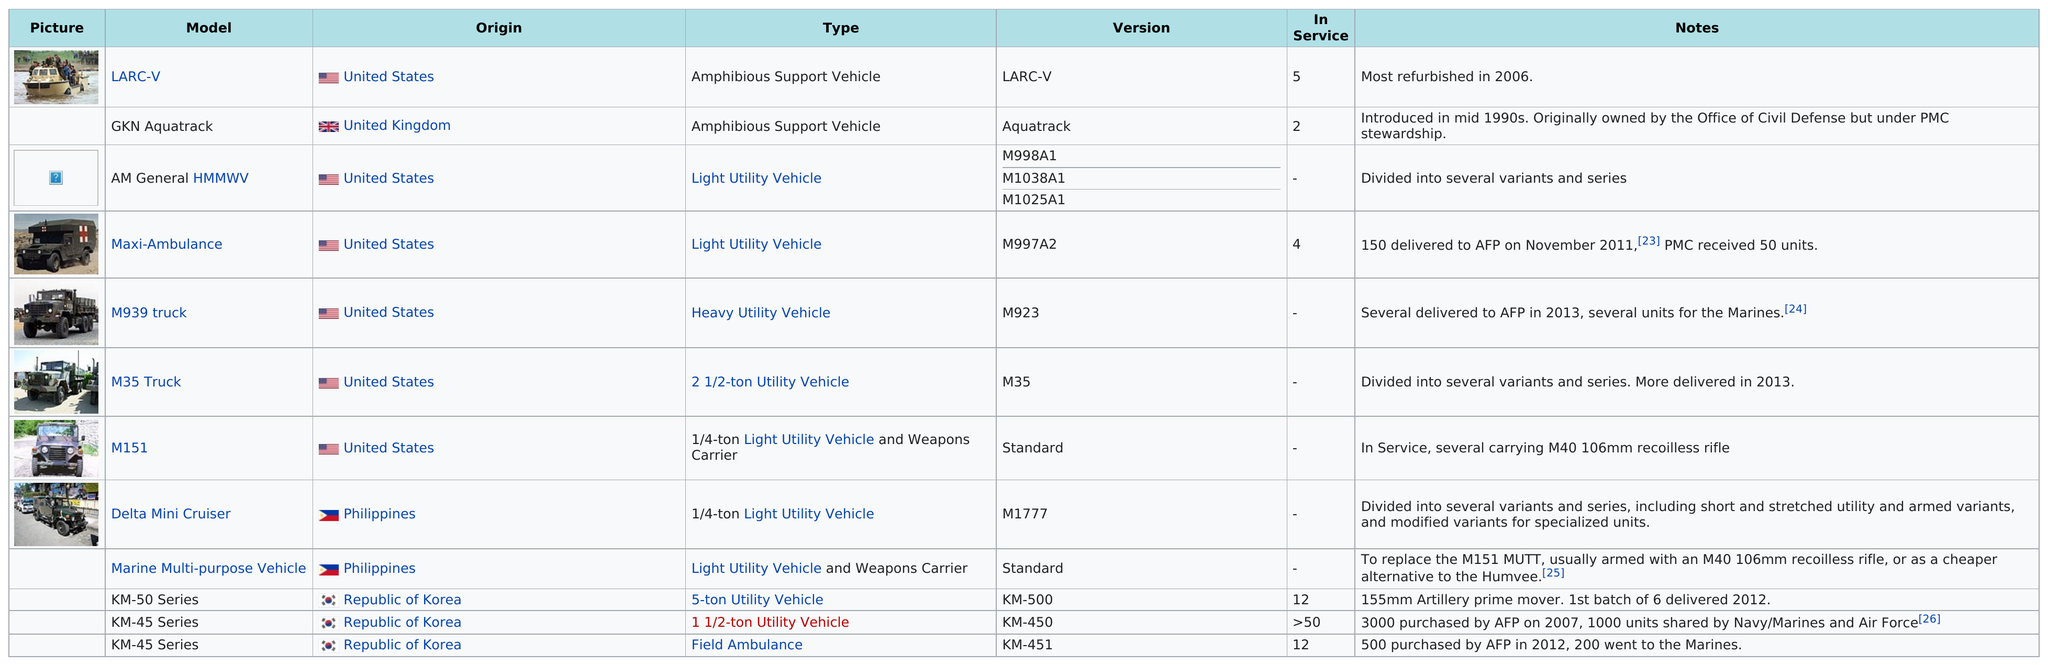Highlight a few significant elements in this photo. Yes, in the chart, the AM General HMMWV is listed before the Maxi-Ambulance. The total number of vehicles originating from the United Kingdom is 1.. The total number of models listed is 12. According to classification, there are 5 light utility vehicle models. It is estimated that there are approximately 5 utility vehicle models that originated in the United States. 